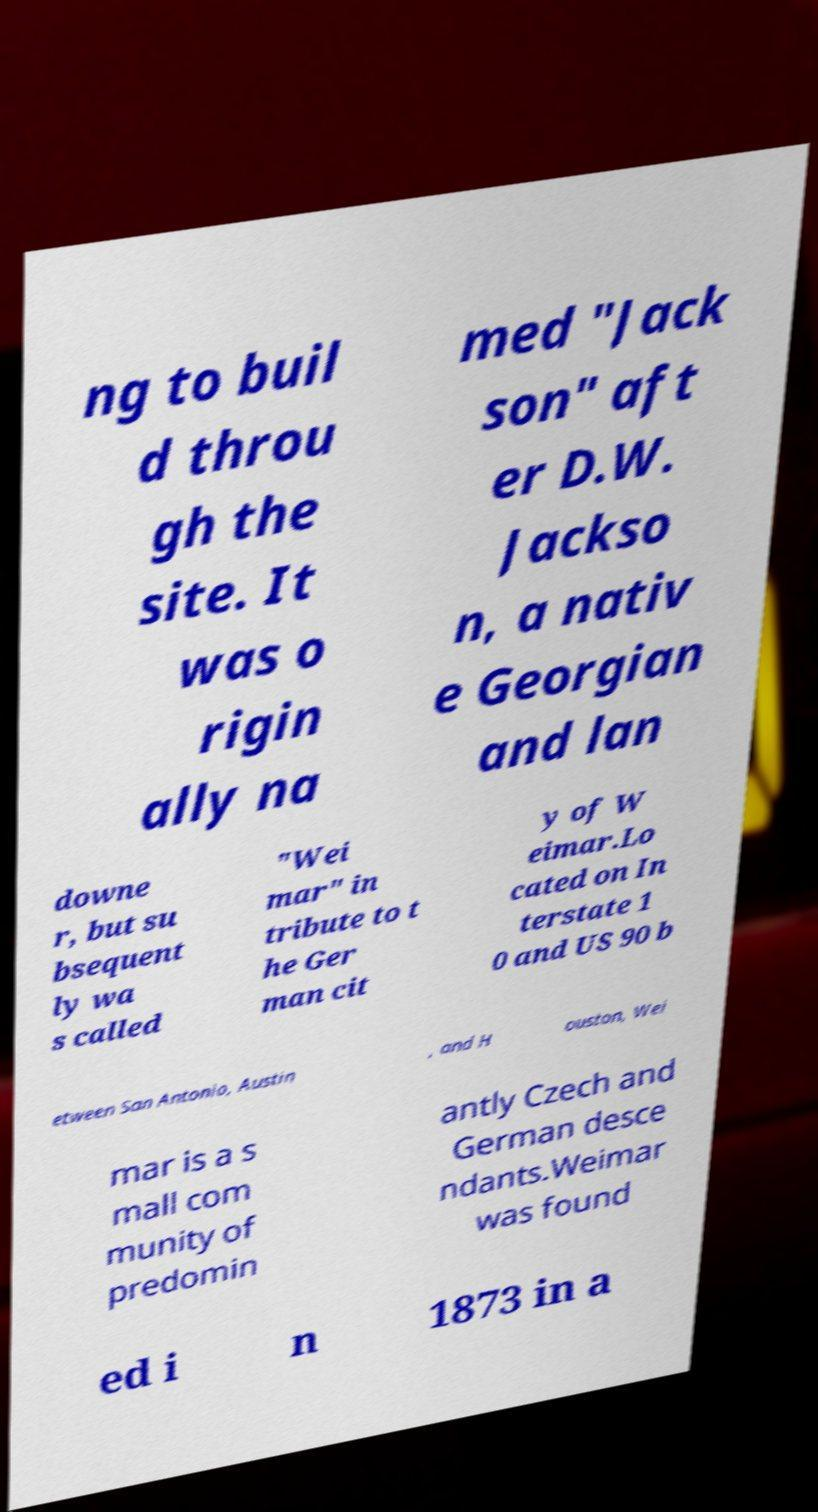What messages or text are displayed in this image? I need them in a readable, typed format. ng to buil d throu gh the site. It was o rigin ally na med "Jack son" aft er D.W. Jackso n, a nativ e Georgian and lan downe r, but su bsequent ly wa s called "Wei mar" in tribute to t he Ger man cit y of W eimar.Lo cated on In terstate 1 0 and US 90 b etween San Antonio, Austin , and H ouston, Wei mar is a s mall com munity of predomin antly Czech and German desce ndants.Weimar was found ed i n 1873 in a 